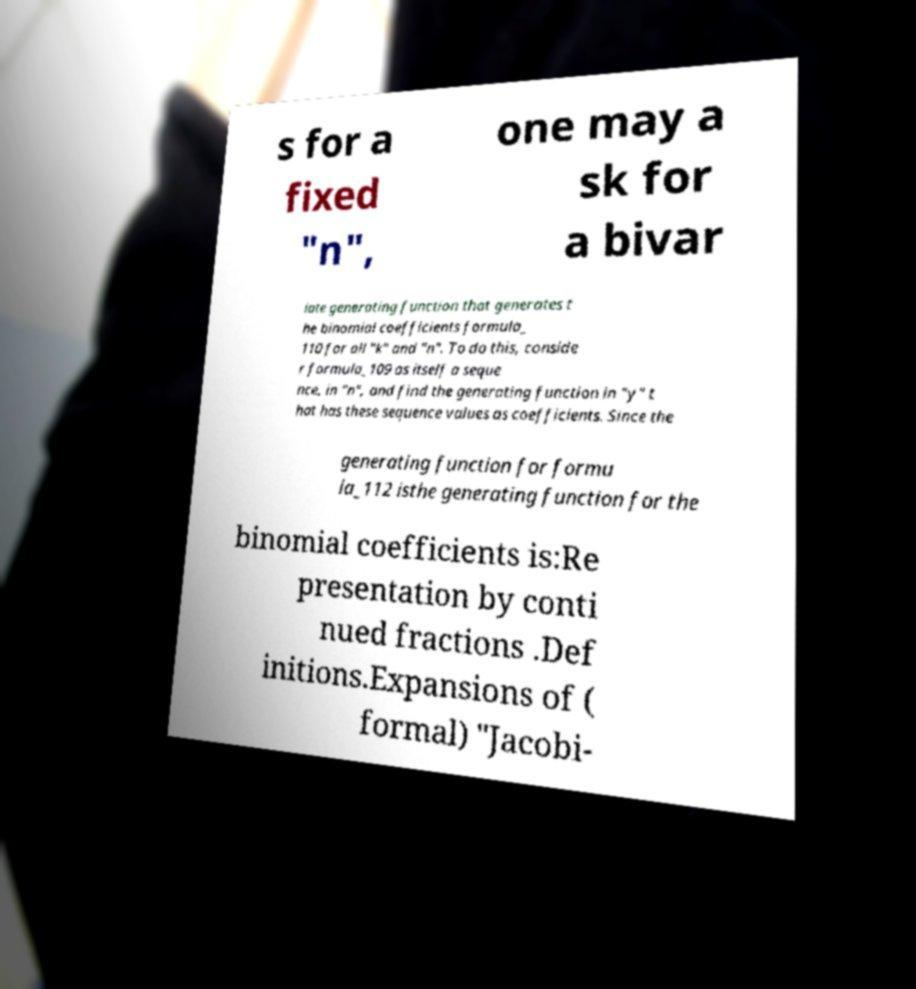There's text embedded in this image that I need extracted. Can you transcribe it verbatim? s for a fixed "n", one may a sk for a bivar iate generating function that generates t he binomial coefficients formula_ 110 for all "k" and "n". To do this, conside r formula_109 as itself a seque nce, in "n", and find the generating function in "y" t hat has these sequence values as coefficients. Since the generating function for formu la_112 isthe generating function for the binomial coefficients is:Re presentation by conti nued fractions .Def initions.Expansions of ( formal) "Jacobi- 